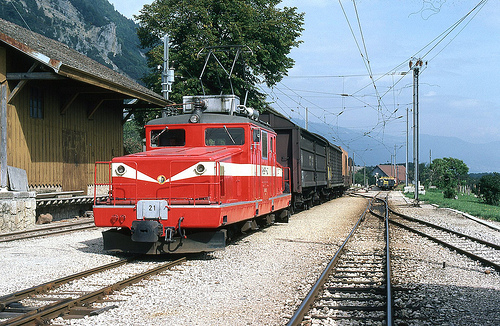Which kind of vehicle is red? The red vehicle in the image is a locomotive, used for pulling freight cars. 